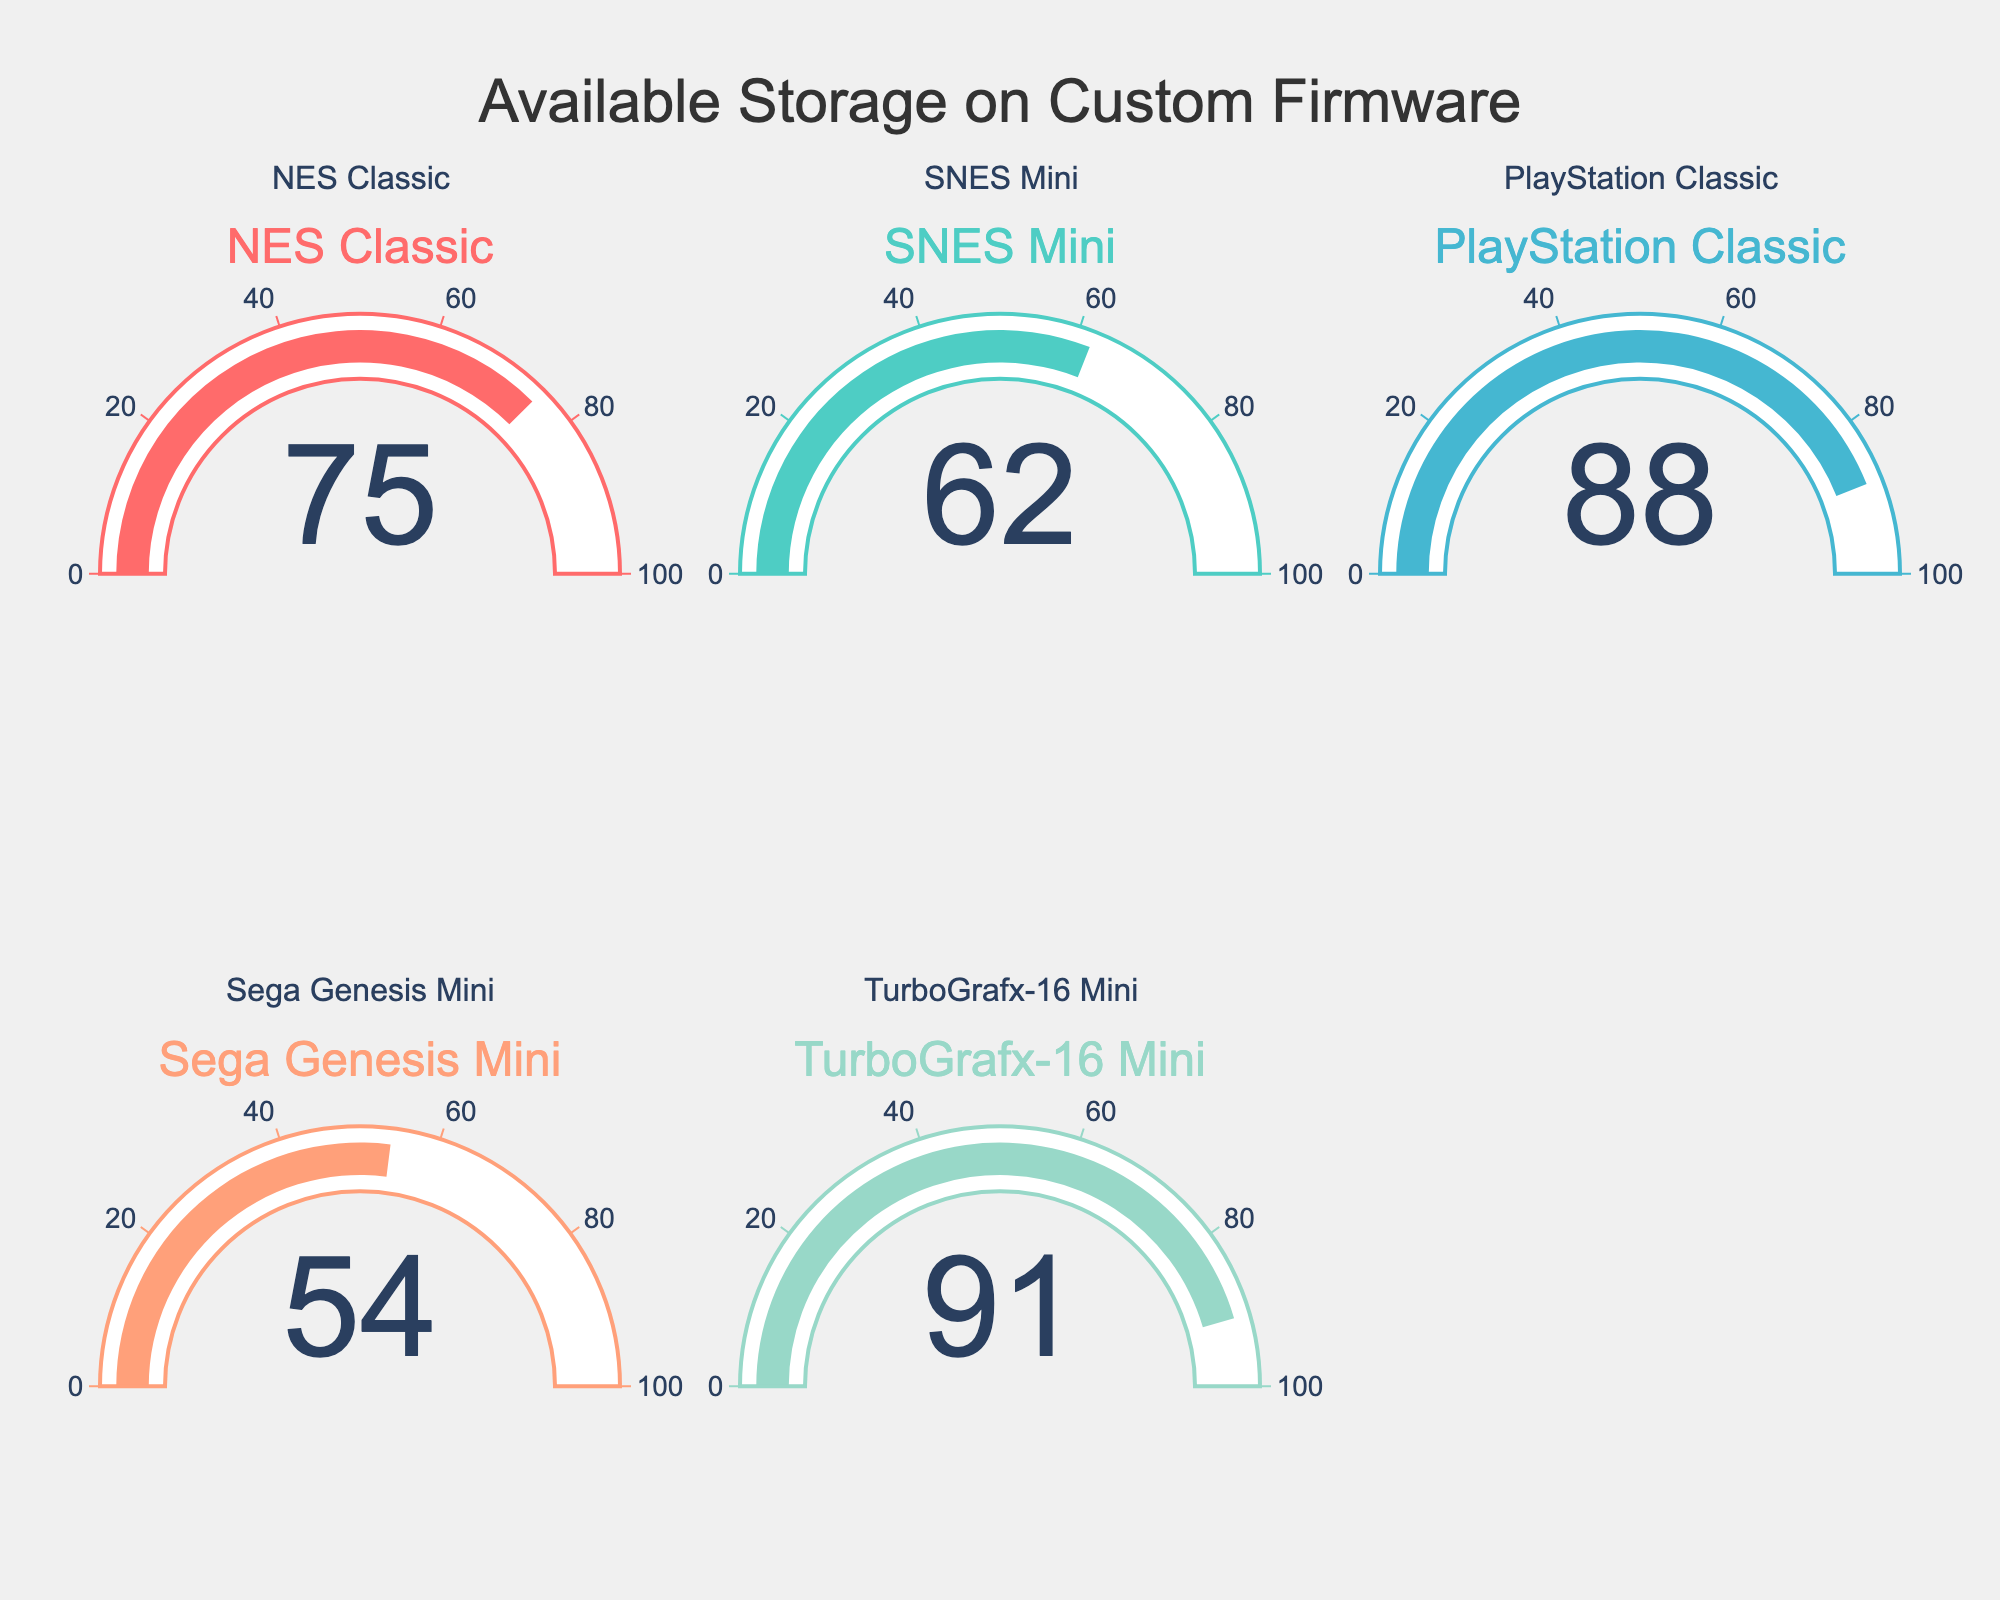What's the highest available storage space on the custom firmware? The highest available storage percentage is indicated by the gauge with the highest value. Out of the five consoles, the TurboGrafx-16 Mini shows the highest value, which is 91%.
Answer: 91% Which console has the lowest available storage space? To find the console with the lowest available storage, look at the gauges and identify the one with the smallest percentage. The Sega Genesis Mini displays the lowest percentage, which is 54%.
Answer: Sega Genesis Mini What is the average available storage space across all consoles? Adding up the available storage percentages of all consoles: 75 + 62 + 88 + 54 + 91 = 370. Then, divide by the number of consoles, 370 / 5 = 74%.
Answer: 74% How much higher is the available storage space of the PlayStation Classic compared to the SNES Mini? Subtract the available storage percentage of the SNES Mini from that of the PlayStation Classic: 88% - 62% = 26%.
Answer: 26% Which consoles have an available storage space greater than 80%? Look at each gauge and note the ones with a value greater than 80%. The PlayStation Classic and TurboGrafx-16 Mini both have values over 80%, with 88% and 91%, respectively.
Answer: PlayStation Classic, TurboGrafx-16 Mini What's the difference between the highest and the lowest available storage space percentages? To find the difference, subtract the lowest available storage percentage (54%) from the highest (91%): 91% - 54% = 37%.
Answer: 37% Is there any console with an available storage space between 60% and 70%? Look at the gauge values and see if any fall within the range 60% to 70%. The SNES Mini has a value of 62%, which falls within this range.
Answer: SNES Mini What is the median available storage space across the consoles? When arranging the storage percentages in increasing order: 54%, 62%, 75%, 88%, 91%, the median is the middle value, which is 75%.
Answer: 75% 